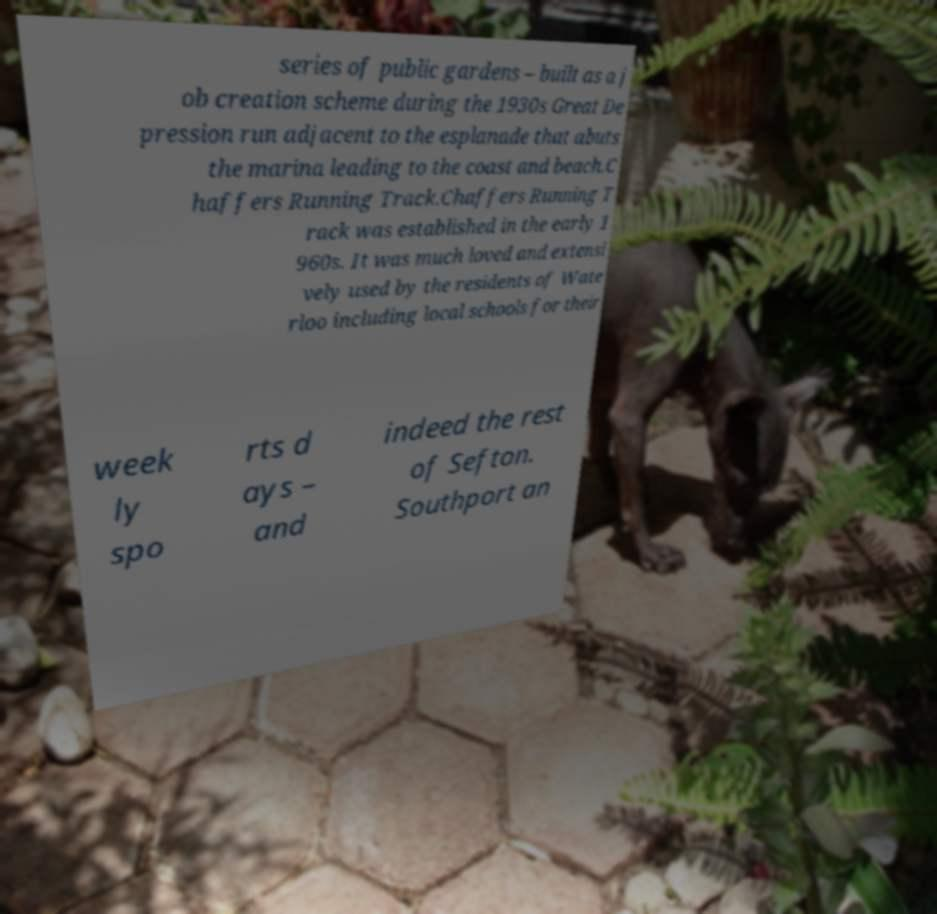There's text embedded in this image that I need extracted. Can you transcribe it verbatim? series of public gardens – built as a j ob creation scheme during the 1930s Great De pression run adjacent to the esplanade that abuts the marina leading to the coast and beach.C haffers Running Track.Chaffers Running T rack was established in the early 1 960s. It was much loved and extensi vely used by the residents of Wate rloo including local schools for their week ly spo rts d ays – and indeed the rest of Sefton. Southport an 